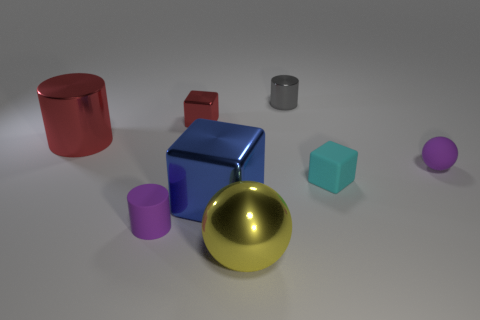Add 1 cylinders. How many objects exist? 9 Subtract all spheres. How many objects are left? 6 Add 3 tiny brown metal things. How many tiny brown metal things exist? 3 Subtract 1 red cylinders. How many objects are left? 7 Subtract all small gray things. Subtract all green cylinders. How many objects are left? 7 Add 8 gray metal cylinders. How many gray metal cylinders are left? 9 